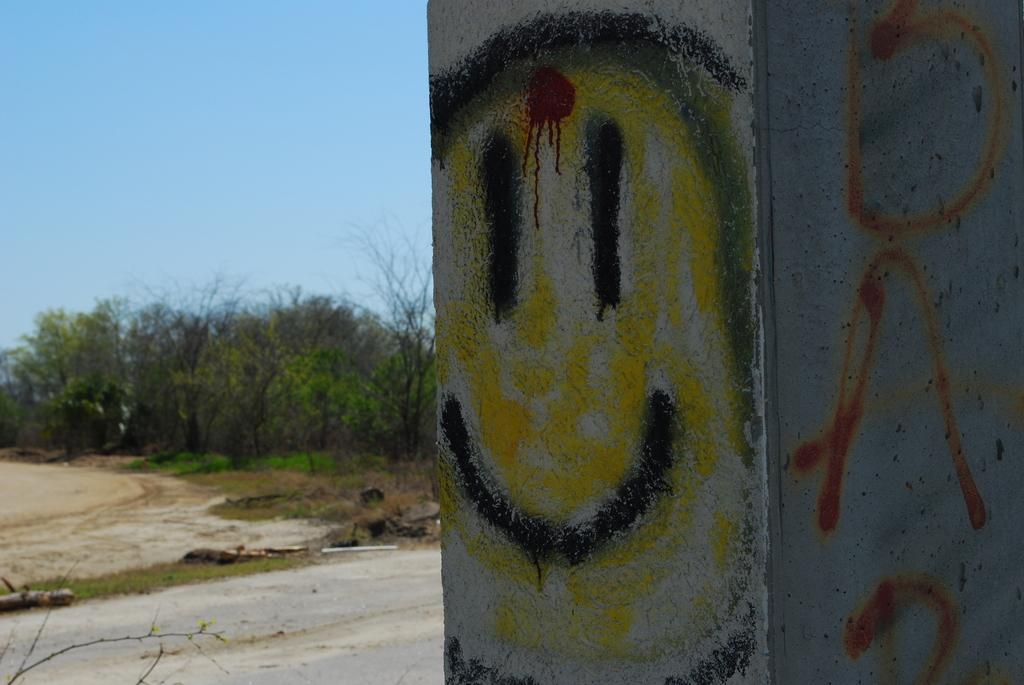What is located on the right side of the image? There is a wall on the right side of the image. What type of vegetation is on the left side of the image? There are trees on the left side of the image. What is visible at the top of the image? The sky is visible at the top of the image. How many roses can be seen growing near the wall in the image? There are no roses present in the image; it features a wall and trees. What type of book is lying on the ground near the trees in the image? There is no book present in the image; it only features a wall, trees, and the sky. 